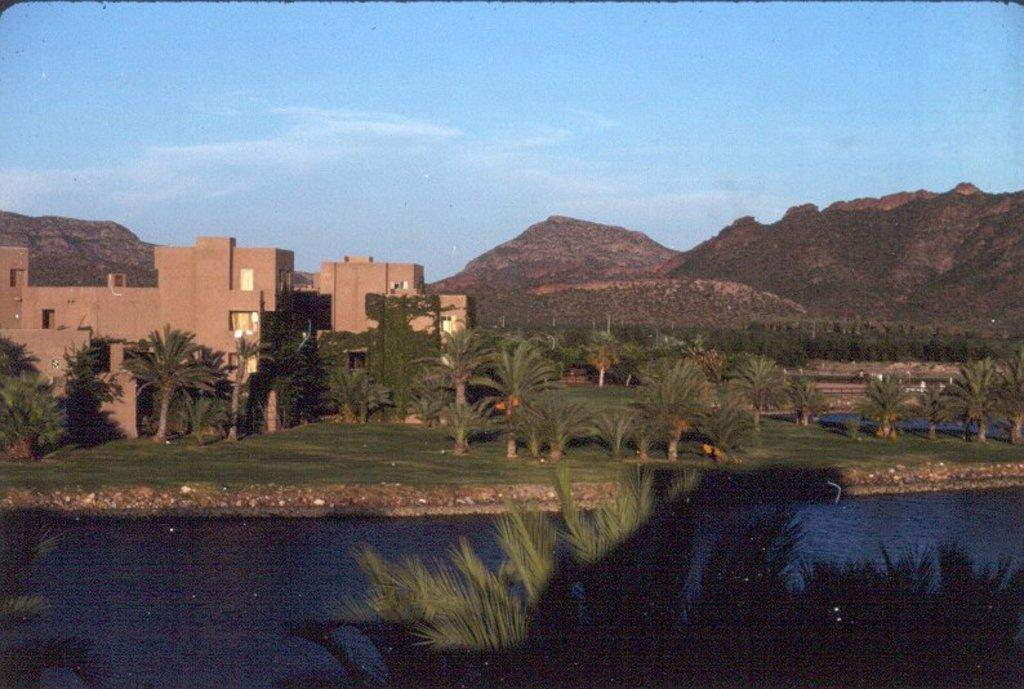What type of structures can be seen in the image? There are buildings in the image. What type of natural vegetation is present in the image? There are trees in the image. What type of natural geological formation is present in the image? There are mountains in the image. What type of natural water body is present in the image? There is a lake in the image. What is the color of the sky in the image? The sky is blue in the image. Can you tell me which direction the cloud is moving in the image? There is no cloud present in the image. What type of trick is being performed in the image? There is no trick being performed in the image. 